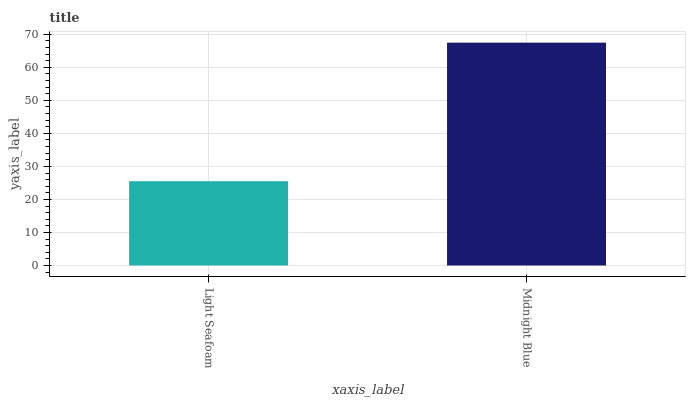Is Midnight Blue the minimum?
Answer yes or no. No. Is Midnight Blue greater than Light Seafoam?
Answer yes or no. Yes. Is Light Seafoam less than Midnight Blue?
Answer yes or no. Yes. Is Light Seafoam greater than Midnight Blue?
Answer yes or no. No. Is Midnight Blue less than Light Seafoam?
Answer yes or no. No. Is Midnight Blue the high median?
Answer yes or no. Yes. Is Light Seafoam the low median?
Answer yes or no. Yes. Is Light Seafoam the high median?
Answer yes or no. No. Is Midnight Blue the low median?
Answer yes or no. No. 